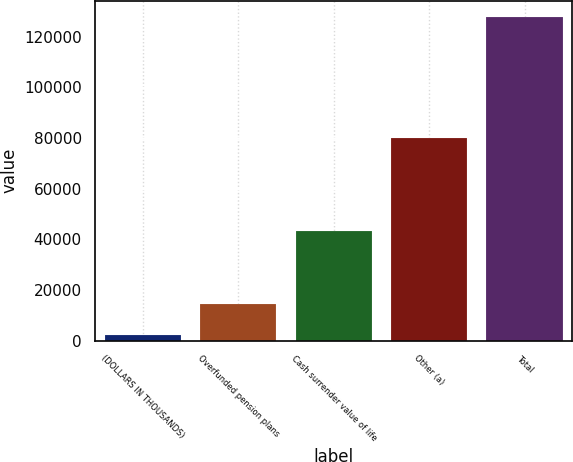<chart> <loc_0><loc_0><loc_500><loc_500><bar_chart><fcel>(DOLLARS IN THOUSANDS)<fcel>Overfunded pension plans<fcel>Cash surrender value of life<fcel>Other (a)<fcel>Total<nl><fcel>2016<fcel>14585.6<fcel>43425<fcel>79944<fcel>127712<nl></chart> 